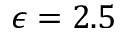<formula> <loc_0><loc_0><loc_500><loc_500>\epsilon = 2 . 5</formula> 